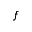<formula> <loc_0><loc_0><loc_500><loc_500>f</formula> 